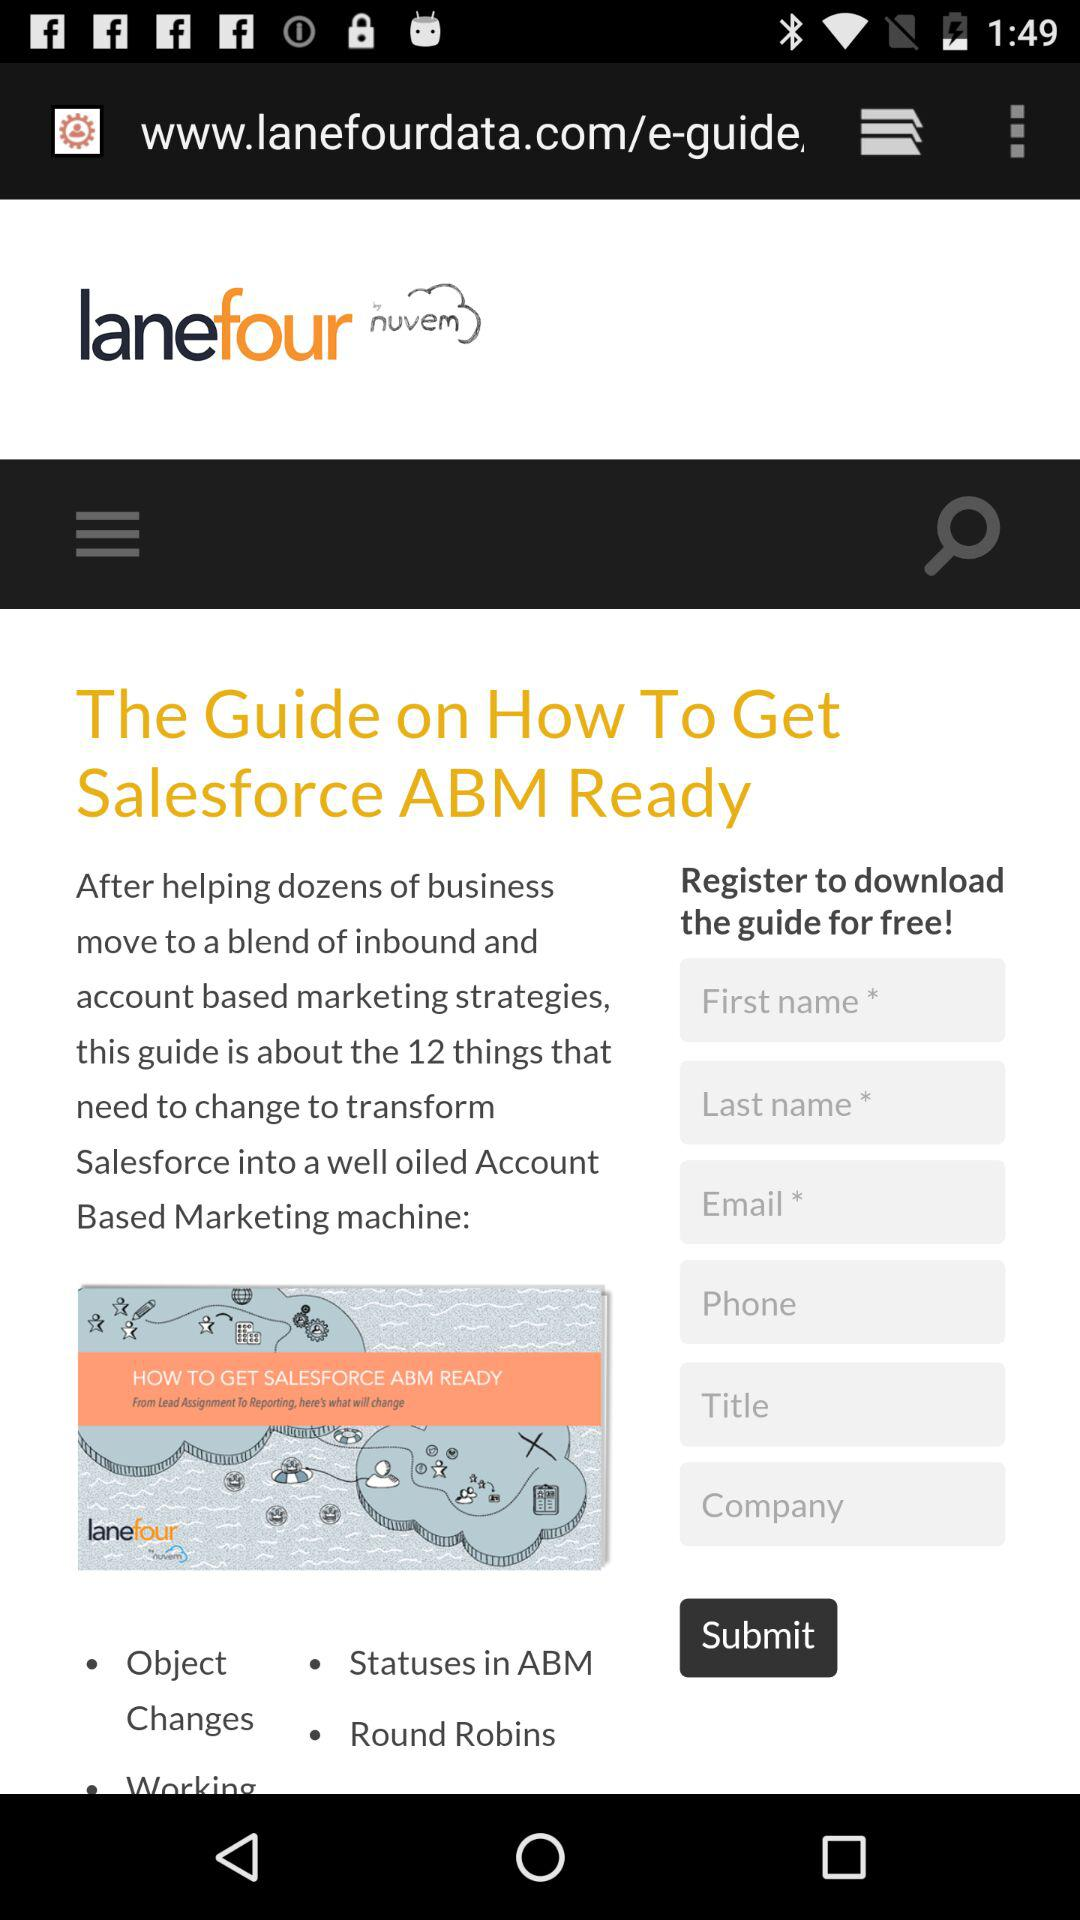What is the application name? The application name is "lanefour". 